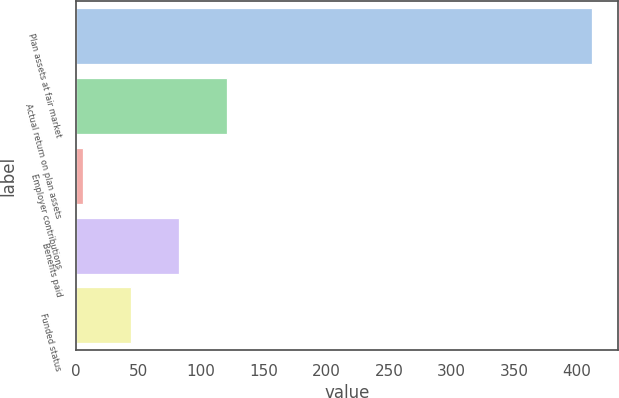Convert chart. <chart><loc_0><loc_0><loc_500><loc_500><bar_chart><fcel>Plan assets at fair market<fcel>Actual return on plan assets<fcel>Employer contributions<fcel>Benefits paid<fcel>Funded status<nl><fcel>412.46<fcel>120.88<fcel>5.8<fcel>82.52<fcel>44.16<nl></chart> 